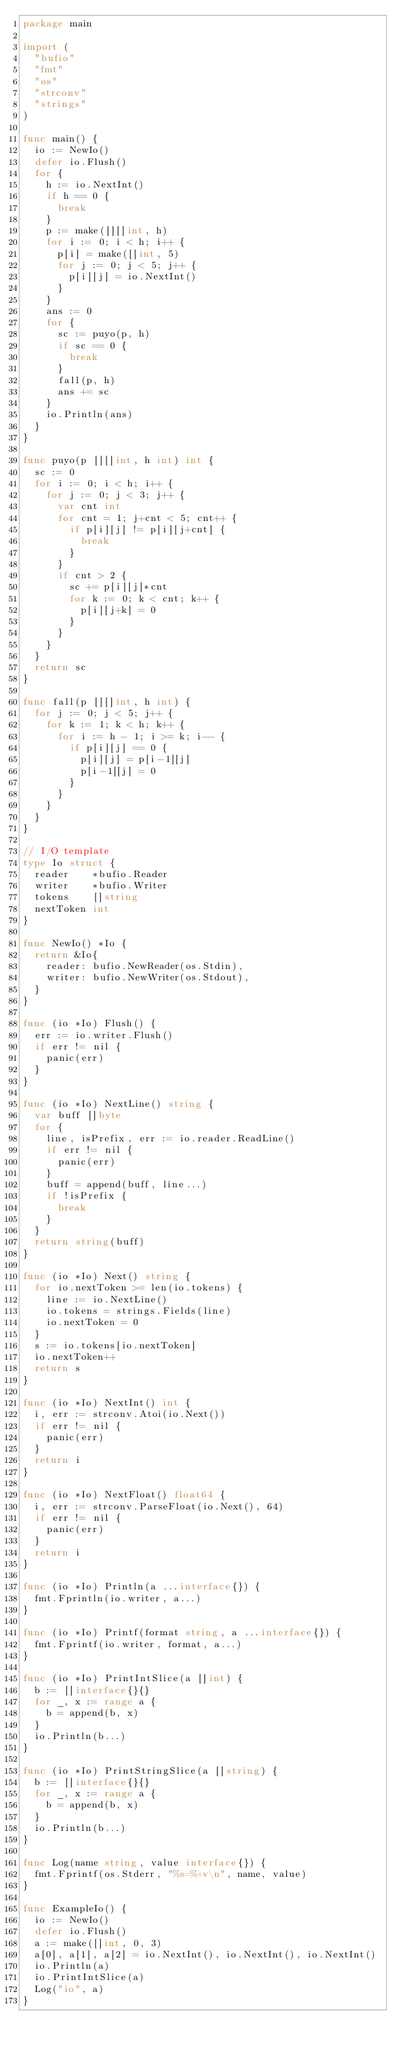Convert code to text. <code><loc_0><loc_0><loc_500><loc_500><_Go_>package main

import (
	"bufio"
	"fmt"
	"os"
	"strconv"
	"strings"
)

func main() {
	io := NewIo()
	defer io.Flush()
	for {
		h := io.NextInt()
		if h == 0 {
			break
		}
		p := make([][]int, h)
		for i := 0; i < h; i++ {
			p[i] = make([]int, 5)
			for j := 0; j < 5; j++ {
				p[i][j] = io.NextInt()
			}
		}
		ans := 0
		for {
			sc := puyo(p, h)
			if sc == 0 {
				break
			}
			fall(p, h)
			ans += sc
		}
		io.Println(ans)
	}
}

func puyo(p [][]int, h int) int {
	sc := 0
	for i := 0; i < h; i++ {
		for j := 0; j < 3; j++ {
			var cnt int
			for cnt = 1; j+cnt < 5; cnt++ {
				if p[i][j] != p[i][j+cnt] {
					break
				}
			}
			if cnt > 2 {
				sc += p[i][j]*cnt
				for k := 0; k < cnt; k++ {
					p[i][j+k] = 0
				}
			}
		}
	}
	return sc
}

func fall(p [][]int, h int) {
	for j := 0; j < 5; j++ {
		for k := 1; k < h; k++ {
			for i := h - 1; i >= k; i-- {
				if p[i][j] == 0 {
					p[i][j] = p[i-1][j]
					p[i-1][j] = 0
				}
			}
		}
	}
}

// I/O template
type Io struct {
	reader    *bufio.Reader
	writer    *bufio.Writer
	tokens    []string
	nextToken int
}

func NewIo() *Io {
	return &Io{
		reader: bufio.NewReader(os.Stdin),
		writer: bufio.NewWriter(os.Stdout),
	}
}

func (io *Io) Flush() {
	err := io.writer.Flush()
	if err != nil {
		panic(err)
	}
}

func (io *Io) NextLine() string {
	var buff []byte
	for {
		line, isPrefix, err := io.reader.ReadLine()
		if err != nil {
			panic(err)
		}
		buff = append(buff, line...)
		if !isPrefix {
			break
		}
	}
	return string(buff)
}

func (io *Io) Next() string {
	for io.nextToken >= len(io.tokens) {
		line := io.NextLine()
		io.tokens = strings.Fields(line)
		io.nextToken = 0
	}
	s := io.tokens[io.nextToken]
	io.nextToken++
	return s
}

func (io *Io) NextInt() int {
	i, err := strconv.Atoi(io.Next())
	if err != nil {
		panic(err)
	}
	return i
}

func (io *Io) NextFloat() float64 {
	i, err := strconv.ParseFloat(io.Next(), 64)
	if err != nil {
		panic(err)
	}
	return i
}

func (io *Io) Println(a ...interface{}) {
	fmt.Fprintln(io.writer, a...)
}

func (io *Io) Printf(format string, a ...interface{}) {
	fmt.Fprintf(io.writer, format, a...)
}

func (io *Io) PrintIntSlice(a []int) {
	b := []interface{}{}
	for _, x := range a {
		b = append(b, x)
	}
	io.Println(b...)
}

func (io *Io) PrintStringSlice(a []string) {
	b := []interface{}{}
	for _, x := range a {
		b = append(b, x)
	}
	io.Println(b...)
}

func Log(name string, value interface{}) {
	fmt.Fprintf(os.Stderr, "%s=%+v\n", name, value)
}

func ExampleIo() {
	io := NewIo()
	defer io.Flush()
	a := make([]int, 0, 3)
	a[0], a[1], a[2] = io.NextInt(), io.NextInt(), io.NextInt()
	io.Println(a)
	io.PrintIntSlice(a)
	Log("io", a)
}

</code> 